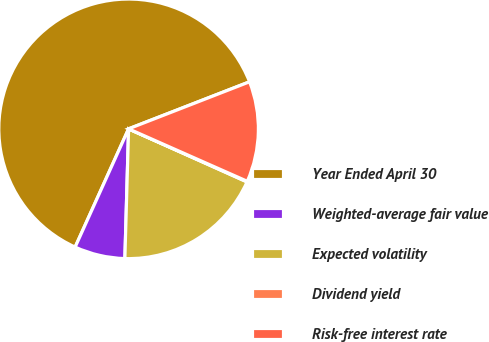<chart> <loc_0><loc_0><loc_500><loc_500><pie_chart><fcel>Year Ended April 30<fcel>Weighted-average fair value<fcel>Expected volatility<fcel>Dividend yield<fcel>Risk-free interest rate<nl><fcel>62.34%<fcel>6.3%<fcel>18.75%<fcel>0.08%<fcel>12.53%<nl></chart> 